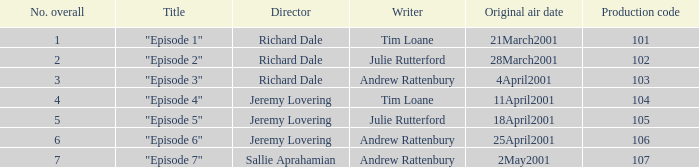When did the episode first air that had a production code of 102? 28March2001. Could you parse the entire table as a dict? {'header': ['No. overall', 'Title', 'Director', 'Writer', 'Original air date', 'Production code'], 'rows': [['1', '"Episode 1"', 'Richard Dale', 'Tim Loane', '21March2001', '101'], ['2', '"Episode 2"', 'Richard Dale', 'Julie Rutterford', '28March2001', '102'], ['3', '"Episode 3"', 'Richard Dale', 'Andrew Rattenbury', '4April2001', '103'], ['4', '"Episode 4"', 'Jeremy Lovering', 'Tim Loane', '11April2001', '104'], ['5', '"Episode 5"', 'Jeremy Lovering', 'Julie Rutterford', '18April2001', '105'], ['6', '"Episode 6"', 'Jeremy Lovering', 'Andrew Rattenbury', '25April2001', '106'], ['7', '"Episode 7"', 'Sallie Aprahamian', 'Andrew Rattenbury', '2May2001', '107']]} 